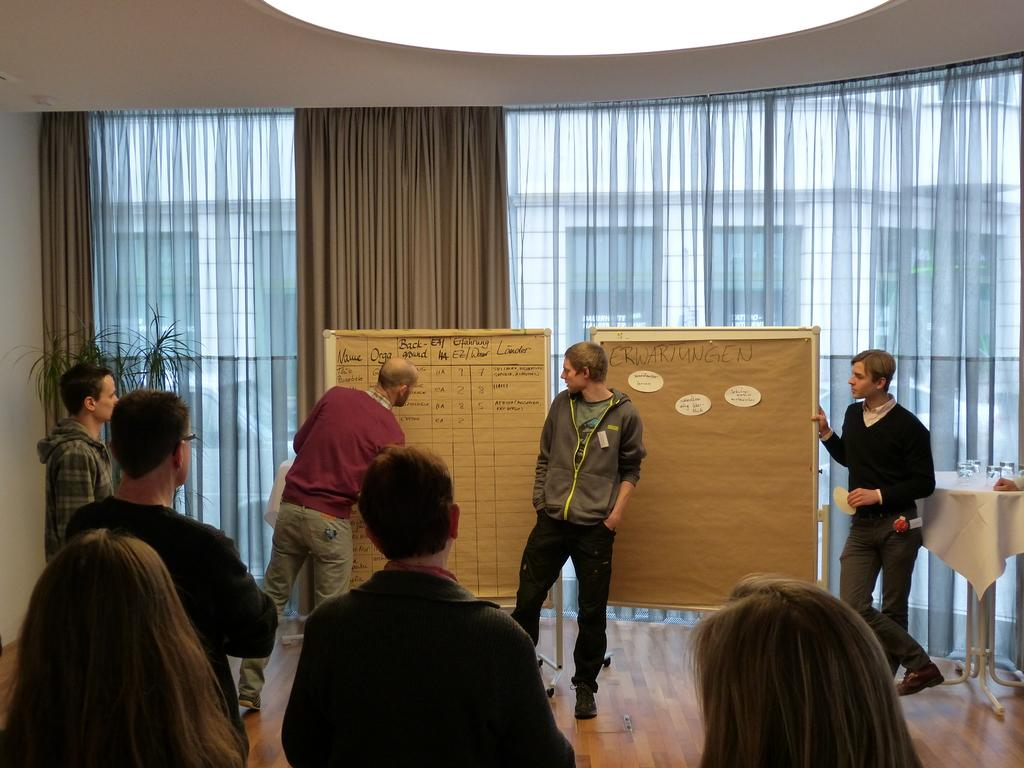What type of structure can be seen in the image? There is a wall in the image. What type of window treatment is present in the image? There are curtains in the image. Are there any people visible in the image? Yes, there are people standing in the image. What is the flat surface with a board on it called in the image? There is a table in the image. What objects are on the table in the image? There are glasses on the table. What type of notebook is being used by the people standing on the sidewalk in the image? There is no notebook or sidewalk present in the image. What type of wine is being served in the glasses on the table in the image? There is no indication of the contents of the glasses in the image. 